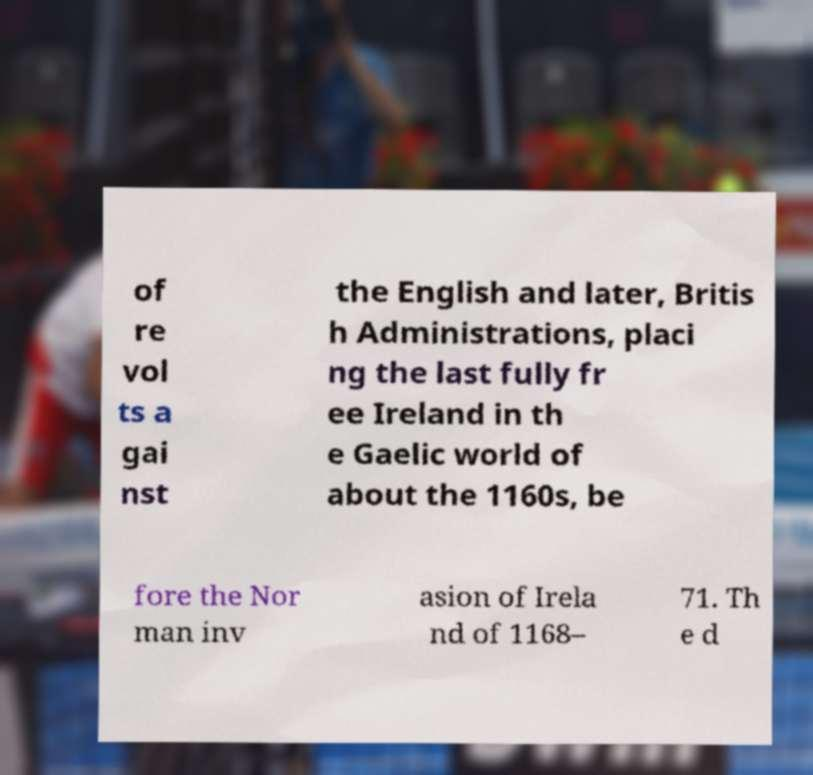Can you accurately transcribe the text from the provided image for me? of re vol ts a gai nst the English and later, Britis h Administrations, placi ng the last fully fr ee Ireland in th e Gaelic world of about the 1160s, be fore the Nor man inv asion of Irela nd of 1168– 71. Th e d 